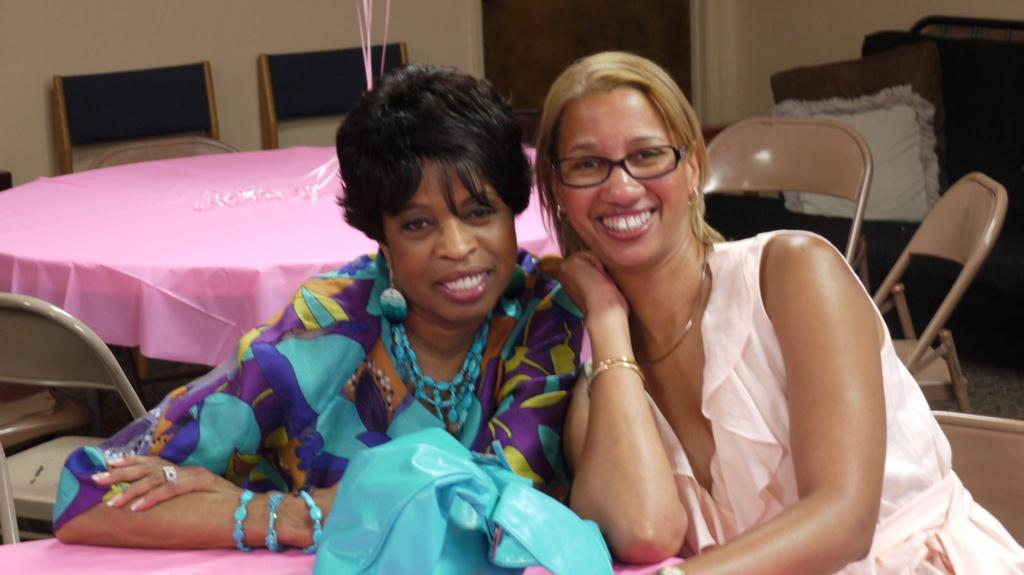How many women are present in the image? There are two women in the image. What is the facial expression of the women? Both women are smiling. Can you describe one of the women's appearance? One of the women is wearing spectacles. What is covering the table in the image? There is a table cloth visible in the image. What type of furniture can be seen in the image? There are chairs in the image. What is the background of the image? There is a wall in the image. What type of soft furnishings are present in the image? There are pillows in the image. What color is the rock near the volcano in the image? There is no rock or volcano present in the image; it features two women, a table cloth, chairs, a wall, and pillows. 